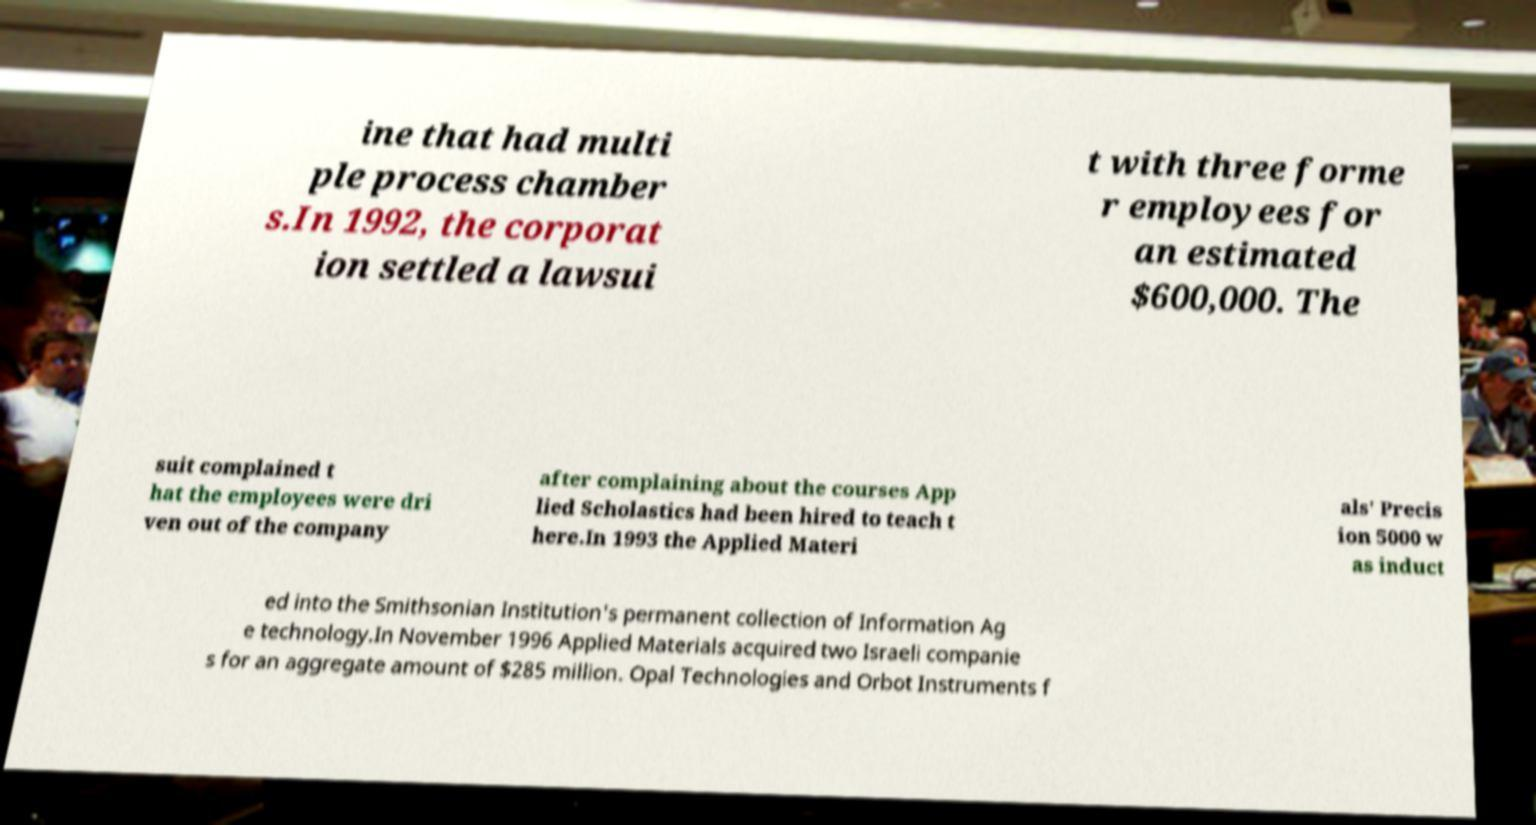I need the written content from this picture converted into text. Can you do that? ine that had multi ple process chamber s.In 1992, the corporat ion settled a lawsui t with three forme r employees for an estimated $600,000. The suit complained t hat the employees were dri ven out of the company after complaining about the courses App lied Scholastics had been hired to teach t here.In 1993 the Applied Materi als' Precis ion 5000 w as induct ed into the Smithsonian Institution's permanent collection of Information Ag e technology.In November 1996 Applied Materials acquired two Israeli companie s for an aggregate amount of $285 million. Opal Technologies and Orbot Instruments f 